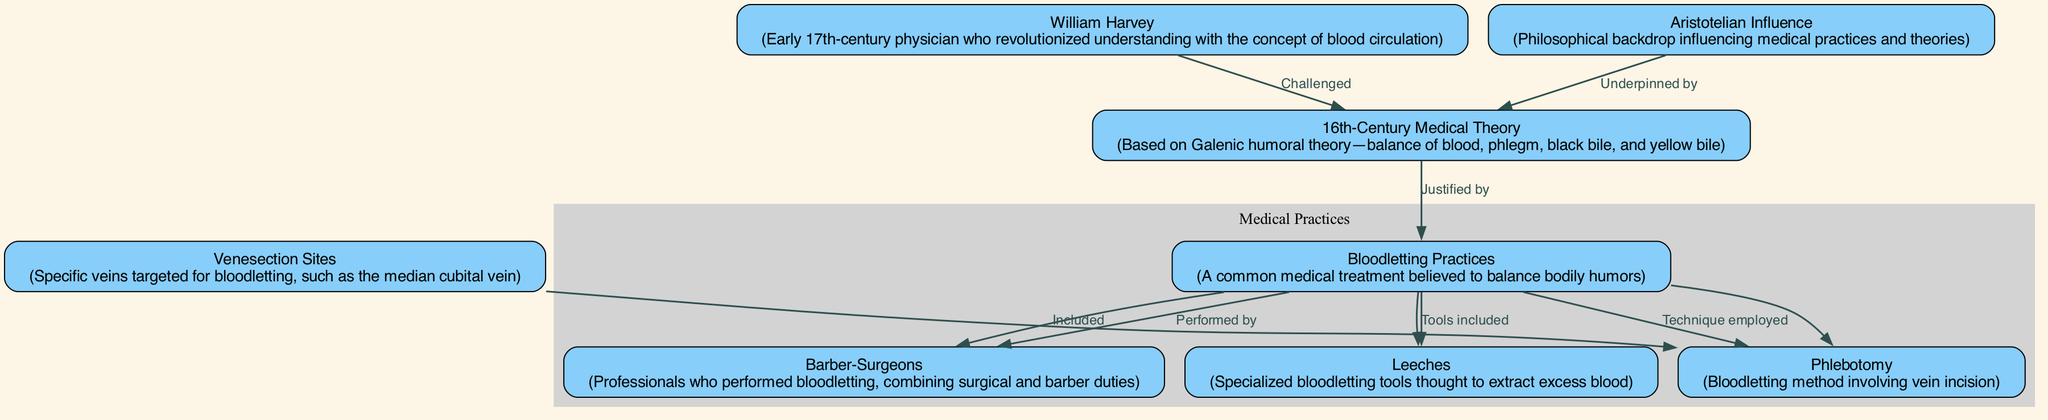What is bloodletting believed to balance? Bloodletting is believed to balance bodily humors according to the 16th-century medical theory. The diagram specifically states that bloodletting practices serve this purpose.
Answer: Bodily humors Who performed bloodletting? The diagram directly indicates that bloodletting practices were performed by barber-surgeons. This relationship is explicitly connected in the diagram's edges.
Answer: Barber-surgeons What method involves vein incision? The diagram includes a node labeled "Phlebotomy," which is specifically defined as the bloodletting method involving vein incision. Thus, it is the correct answer.
Answer: Phlebotomy Which medical theory justified bloodletting practices? The 16th-Century Medical Theory is shown in the diagram as the basis that justified bloodletting practices. This connection is established by a directed edge in the diagram.
Answer: 16th-Century Medical Theory How many venesection sites are included in the diagram? The diagram specifies one primary venesection site related to the technique of phlebotomy, which is the median cubital vein. Counting the mentioned sites results in one.
Answer: One What concept did William Harvey challenge? The diagram indicates that William Harvey challenged the 16th-Century Medical Theory, which was based on the balance of humors. This relationship between both nodes is described in the edges around the theory.
Answer: 16th-Century Medical Theory Which specialized tool was used for bloodletting? The diagram lists leeches as a specialized bloodletting tool. This is explained within the context of the bloodletting practices and clearly demonstrates their application.
Answer: Leeches What philosophical influence underpinned 16th-century medical theory? The diagram specifies Aristotelian Influence as the philosophical backdrop that underpinned the 16th-century medical theory. This is clarified through a direct relationship indicated in the edges.
Answer: Aristotelian Influence Which technique employed is specifically identified in the diagram? The technique labeled as "Phlebotomy" is clearly identified in the diagram as one of the employed methods of bloodletting. This is indicated in the direct relationships present among the nodes.
Answer: Phlebotomy 